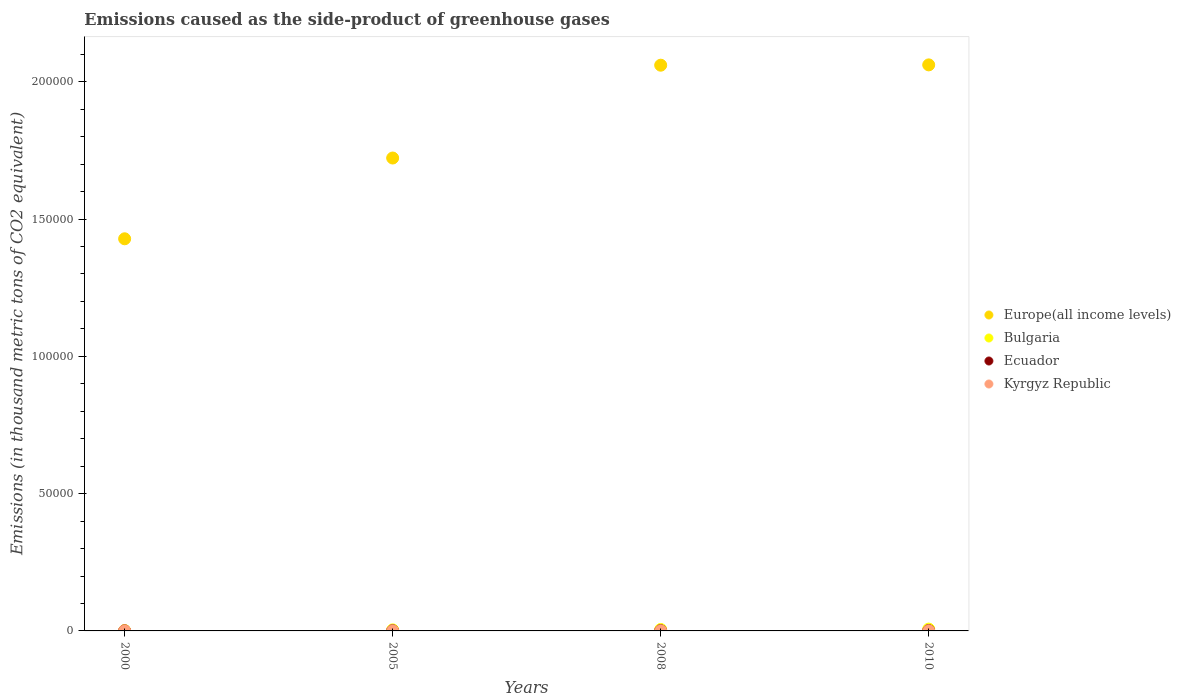What is the emissions caused as the side-product of greenhouse gases in Europe(all income levels) in 2005?
Your answer should be very brief. 1.72e+05. Across all years, what is the maximum emissions caused as the side-product of greenhouse gases in Europe(all income levels)?
Your response must be concise. 2.06e+05. Across all years, what is the minimum emissions caused as the side-product of greenhouse gases in Europe(all income levels)?
Give a very brief answer. 1.43e+05. In which year was the emissions caused as the side-product of greenhouse gases in Kyrgyz Republic maximum?
Your response must be concise. 2010. What is the total emissions caused as the side-product of greenhouse gases in Ecuador in the graph?
Your answer should be very brief. 272.6. What is the difference between the emissions caused as the side-product of greenhouse gases in Europe(all income levels) in 2000 and that in 2010?
Provide a succinct answer. -6.33e+04. What is the difference between the emissions caused as the side-product of greenhouse gases in Bulgaria in 2005 and the emissions caused as the side-product of greenhouse gases in Ecuador in 2000?
Offer a terse response. 360.4. What is the average emissions caused as the side-product of greenhouse gases in Kyrgyz Republic per year?
Make the answer very short. 27.17. In the year 2000, what is the difference between the emissions caused as the side-product of greenhouse gases in Kyrgyz Republic and emissions caused as the side-product of greenhouse gases in Bulgaria?
Your answer should be compact. -114.3. What is the ratio of the emissions caused as the side-product of greenhouse gases in Kyrgyz Republic in 2000 to that in 2008?
Offer a very short reply. 0.23. Is the emissions caused as the side-product of greenhouse gases in Ecuador in 2008 less than that in 2010?
Your response must be concise. Yes. Is the difference between the emissions caused as the side-product of greenhouse gases in Kyrgyz Republic in 2000 and 2005 greater than the difference between the emissions caused as the side-product of greenhouse gases in Bulgaria in 2000 and 2005?
Provide a short and direct response. Yes. What is the difference between the highest and the second highest emissions caused as the side-product of greenhouse gases in Europe(all income levels)?
Give a very brief answer. 115.6. What is the difference between the highest and the lowest emissions caused as the side-product of greenhouse gases in Ecuador?
Provide a short and direct response. 84.3. In how many years, is the emissions caused as the side-product of greenhouse gases in Bulgaria greater than the average emissions caused as the side-product of greenhouse gases in Bulgaria taken over all years?
Your answer should be very brief. 2. Is it the case that in every year, the sum of the emissions caused as the side-product of greenhouse gases in Bulgaria and emissions caused as the side-product of greenhouse gases in Kyrgyz Republic  is greater than the sum of emissions caused as the side-product of greenhouse gases in Ecuador and emissions caused as the side-product of greenhouse gases in Europe(all income levels)?
Offer a terse response. No. Is it the case that in every year, the sum of the emissions caused as the side-product of greenhouse gases in Bulgaria and emissions caused as the side-product of greenhouse gases in Kyrgyz Republic  is greater than the emissions caused as the side-product of greenhouse gases in Ecuador?
Make the answer very short. Yes. What is the difference between two consecutive major ticks on the Y-axis?
Your answer should be very brief. 5.00e+04. Where does the legend appear in the graph?
Keep it short and to the point. Center right. How many legend labels are there?
Give a very brief answer. 4. How are the legend labels stacked?
Your answer should be compact. Vertical. What is the title of the graph?
Offer a terse response. Emissions caused as the side-product of greenhouse gases. What is the label or title of the Y-axis?
Ensure brevity in your answer.  Emissions (in thousand metric tons of CO2 equivalent). What is the Emissions (in thousand metric tons of CO2 equivalent) in Europe(all income levels) in 2000?
Provide a short and direct response. 1.43e+05. What is the Emissions (in thousand metric tons of CO2 equivalent) of Bulgaria in 2000?
Your answer should be very brief. 122.2. What is the Emissions (in thousand metric tons of CO2 equivalent) of Europe(all income levels) in 2005?
Ensure brevity in your answer.  1.72e+05. What is the Emissions (in thousand metric tons of CO2 equivalent) of Bulgaria in 2005?
Offer a very short reply. 380.1. What is the Emissions (in thousand metric tons of CO2 equivalent) of Ecuador in 2005?
Make the answer very short. 62.2. What is the Emissions (in thousand metric tons of CO2 equivalent) in Kyrgyz Republic in 2005?
Your answer should be very brief. 24. What is the Emissions (in thousand metric tons of CO2 equivalent) in Europe(all income levels) in 2008?
Your answer should be compact. 2.06e+05. What is the Emissions (in thousand metric tons of CO2 equivalent) of Bulgaria in 2008?
Provide a succinct answer. 526.2. What is the Emissions (in thousand metric tons of CO2 equivalent) in Ecuador in 2008?
Provide a succinct answer. 86.7. What is the Emissions (in thousand metric tons of CO2 equivalent) of Kyrgyz Republic in 2008?
Your response must be concise. 34.8. What is the Emissions (in thousand metric tons of CO2 equivalent) of Europe(all income levels) in 2010?
Give a very brief answer. 2.06e+05. What is the Emissions (in thousand metric tons of CO2 equivalent) of Bulgaria in 2010?
Make the answer very short. 666. What is the Emissions (in thousand metric tons of CO2 equivalent) in Ecuador in 2010?
Your response must be concise. 104. Across all years, what is the maximum Emissions (in thousand metric tons of CO2 equivalent) of Europe(all income levels)?
Provide a short and direct response. 2.06e+05. Across all years, what is the maximum Emissions (in thousand metric tons of CO2 equivalent) in Bulgaria?
Offer a very short reply. 666. Across all years, what is the maximum Emissions (in thousand metric tons of CO2 equivalent) of Ecuador?
Your answer should be compact. 104. Across all years, what is the minimum Emissions (in thousand metric tons of CO2 equivalent) of Europe(all income levels)?
Provide a short and direct response. 1.43e+05. Across all years, what is the minimum Emissions (in thousand metric tons of CO2 equivalent) in Bulgaria?
Offer a very short reply. 122.2. Across all years, what is the minimum Emissions (in thousand metric tons of CO2 equivalent) in Kyrgyz Republic?
Ensure brevity in your answer.  7.9. What is the total Emissions (in thousand metric tons of CO2 equivalent) of Europe(all income levels) in the graph?
Make the answer very short. 7.27e+05. What is the total Emissions (in thousand metric tons of CO2 equivalent) of Bulgaria in the graph?
Offer a terse response. 1694.5. What is the total Emissions (in thousand metric tons of CO2 equivalent) in Ecuador in the graph?
Ensure brevity in your answer.  272.6. What is the total Emissions (in thousand metric tons of CO2 equivalent) in Kyrgyz Republic in the graph?
Offer a terse response. 108.7. What is the difference between the Emissions (in thousand metric tons of CO2 equivalent) of Europe(all income levels) in 2000 and that in 2005?
Make the answer very short. -2.94e+04. What is the difference between the Emissions (in thousand metric tons of CO2 equivalent) of Bulgaria in 2000 and that in 2005?
Offer a terse response. -257.9. What is the difference between the Emissions (in thousand metric tons of CO2 equivalent) in Ecuador in 2000 and that in 2005?
Give a very brief answer. -42.5. What is the difference between the Emissions (in thousand metric tons of CO2 equivalent) in Kyrgyz Republic in 2000 and that in 2005?
Provide a succinct answer. -16.1. What is the difference between the Emissions (in thousand metric tons of CO2 equivalent) in Europe(all income levels) in 2000 and that in 2008?
Your answer should be very brief. -6.32e+04. What is the difference between the Emissions (in thousand metric tons of CO2 equivalent) of Bulgaria in 2000 and that in 2008?
Provide a succinct answer. -404. What is the difference between the Emissions (in thousand metric tons of CO2 equivalent) in Ecuador in 2000 and that in 2008?
Offer a terse response. -67. What is the difference between the Emissions (in thousand metric tons of CO2 equivalent) in Kyrgyz Republic in 2000 and that in 2008?
Provide a succinct answer. -26.9. What is the difference between the Emissions (in thousand metric tons of CO2 equivalent) in Europe(all income levels) in 2000 and that in 2010?
Your response must be concise. -6.33e+04. What is the difference between the Emissions (in thousand metric tons of CO2 equivalent) in Bulgaria in 2000 and that in 2010?
Provide a short and direct response. -543.8. What is the difference between the Emissions (in thousand metric tons of CO2 equivalent) in Ecuador in 2000 and that in 2010?
Give a very brief answer. -84.3. What is the difference between the Emissions (in thousand metric tons of CO2 equivalent) of Kyrgyz Republic in 2000 and that in 2010?
Your response must be concise. -34.1. What is the difference between the Emissions (in thousand metric tons of CO2 equivalent) of Europe(all income levels) in 2005 and that in 2008?
Your answer should be very brief. -3.38e+04. What is the difference between the Emissions (in thousand metric tons of CO2 equivalent) in Bulgaria in 2005 and that in 2008?
Provide a succinct answer. -146.1. What is the difference between the Emissions (in thousand metric tons of CO2 equivalent) in Ecuador in 2005 and that in 2008?
Ensure brevity in your answer.  -24.5. What is the difference between the Emissions (in thousand metric tons of CO2 equivalent) of Europe(all income levels) in 2005 and that in 2010?
Provide a succinct answer. -3.39e+04. What is the difference between the Emissions (in thousand metric tons of CO2 equivalent) of Bulgaria in 2005 and that in 2010?
Make the answer very short. -285.9. What is the difference between the Emissions (in thousand metric tons of CO2 equivalent) in Ecuador in 2005 and that in 2010?
Keep it short and to the point. -41.8. What is the difference between the Emissions (in thousand metric tons of CO2 equivalent) of Kyrgyz Republic in 2005 and that in 2010?
Keep it short and to the point. -18. What is the difference between the Emissions (in thousand metric tons of CO2 equivalent) in Europe(all income levels) in 2008 and that in 2010?
Make the answer very short. -115.6. What is the difference between the Emissions (in thousand metric tons of CO2 equivalent) in Bulgaria in 2008 and that in 2010?
Give a very brief answer. -139.8. What is the difference between the Emissions (in thousand metric tons of CO2 equivalent) of Ecuador in 2008 and that in 2010?
Ensure brevity in your answer.  -17.3. What is the difference between the Emissions (in thousand metric tons of CO2 equivalent) of Europe(all income levels) in 2000 and the Emissions (in thousand metric tons of CO2 equivalent) of Bulgaria in 2005?
Offer a very short reply. 1.42e+05. What is the difference between the Emissions (in thousand metric tons of CO2 equivalent) of Europe(all income levels) in 2000 and the Emissions (in thousand metric tons of CO2 equivalent) of Ecuador in 2005?
Your answer should be very brief. 1.43e+05. What is the difference between the Emissions (in thousand metric tons of CO2 equivalent) of Europe(all income levels) in 2000 and the Emissions (in thousand metric tons of CO2 equivalent) of Kyrgyz Republic in 2005?
Your answer should be compact. 1.43e+05. What is the difference between the Emissions (in thousand metric tons of CO2 equivalent) of Bulgaria in 2000 and the Emissions (in thousand metric tons of CO2 equivalent) of Kyrgyz Republic in 2005?
Your answer should be very brief. 98.2. What is the difference between the Emissions (in thousand metric tons of CO2 equivalent) of Ecuador in 2000 and the Emissions (in thousand metric tons of CO2 equivalent) of Kyrgyz Republic in 2005?
Ensure brevity in your answer.  -4.3. What is the difference between the Emissions (in thousand metric tons of CO2 equivalent) in Europe(all income levels) in 2000 and the Emissions (in thousand metric tons of CO2 equivalent) in Bulgaria in 2008?
Provide a short and direct response. 1.42e+05. What is the difference between the Emissions (in thousand metric tons of CO2 equivalent) of Europe(all income levels) in 2000 and the Emissions (in thousand metric tons of CO2 equivalent) of Ecuador in 2008?
Your answer should be very brief. 1.43e+05. What is the difference between the Emissions (in thousand metric tons of CO2 equivalent) in Europe(all income levels) in 2000 and the Emissions (in thousand metric tons of CO2 equivalent) in Kyrgyz Republic in 2008?
Your answer should be compact. 1.43e+05. What is the difference between the Emissions (in thousand metric tons of CO2 equivalent) of Bulgaria in 2000 and the Emissions (in thousand metric tons of CO2 equivalent) of Ecuador in 2008?
Give a very brief answer. 35.5. What is the difference between the Emissions (in thousand metric tons of CO2 equivalent) in Bulgaria in 2000 and the Emissions (in thousand metric tons of CO2 equivalent) in Kyrgyz Republic in 2008?
Keep it short and to the point. 87.4. What is the difference between the Emissions (in thousand metric tons of CO2 equivalent) of Ecuador in 2000 and the Emissions (in thousand metric tons of CO2 equivalent) of Kyrgyz Republic in 2008?
Provide a succinct answer. -15.1. What is the difference between the Emissions (in thousand metric tons of CO2 equivalent) of Europe(all income levels) in 2000 and the Emissions (in thousand metric tons of CO2 equivalent) of Bulgaria in 2010?
Your response must be concise. 1.42e+05. What is the difference between the Emissions (in thousand metric tons of CO2 equivalent) of Europe(all income levels) in 2000 and the Emissions (in thousand metric tons of CO2 equivalent) of Ecuador in 2010?
Offer a terse response. 1.43e+05. What is the difference between the Emissions (in thousand metric tons of CO2 equivalent) of Europe(all income levels) in 2000 and the Emissions (in thousand metric tons of CO2 equivalent) of Kyrgyz Republic in 2010?
Offer a very short reply. 1.43e+05. What is the difference between the Emissions (in thousand metric tons of CO2 equivalent) in Bulgaria in 2000 and the Emissions (in thousand metric tons of CO2 equivalent) in Kyrgyz Republic in 2010?
Keep it short and to the point. 80.2. What is the difference between the Emissions (in thousand metric tons of CO2 equivalent) of Ecuador in 2000 and the Emissions (in thousand metric tons of CO2 equivalent) of Kyrgyz Republic in 2010?
Provide a short and direct response. -22.3. What is the difference between the Emissions (in thousand metric tons of CO2 equivalent) of Europe(all income levels) in 2005 and the Emissions (in thousand metric tons of CO2 equivalent) of Bulgaria in 2008?
Provide a succinct answer. 1.72e+05. What is the difference between the Emissions (in thousand metric tons of CO2 equivalent) in Europe(all income levels) in 2005 and the Emissions (in thousand metric tons of CO2 equivalent) in Ecuador in 2008?
Your answer should be very brief. 1.72e+05. What is the difference between the Emissions (in thousand metric tons of CO2 equivalent) in Europe(all income levels) in 2005 and the Emissions (in thousand metric tons of CO2 equivalent) in Kyrgyz Republic in 2008?
Offer a terse response. 1.72e+05. What is the difference between the Emissions (in thousand metric tons of CO2 equivalent) of Bulgaria in 2005 and the Emissions (in thousand metric tons of CO2 equivalent) of Ecuador in 2008?
Provide a short and direct response. 293.4. What is the difference between the Emissions (in thousand metric tons of CO2 equivalent) in Bulgaria in 2005 and the Emissions (in thousand metric tons of CO2 equivalent) in Kyrgyz Republic in 2008?
Give a very brief answer. 345.3. What is the difference between the Emissions (in thousand metric tons of CO2 equivalent) in Ecuador in 2005 and the Emissions (in thousand metric tons of CO2 equivalent) in Kyrgyz Republic in 2008?
Provide a short and direct response. 27.4. What is the difference between the Emissions (in thousand metric tons of CO2 equivalent) of Europe(all income levels) in 2005 and the Emissions (in thousand metric tons of CO2 equivalent) of Bulgaria in 2010?
Offer a terse response. 1.72e+05. What is the difference between the Emissions (in thousand metric tons of CO2 equivalent) of Europe(all income levels) in 2005 and the Emissions (in thousand metric tons of CO2 equivalent) of Ecuador in 2010?
Your response must be concise. 1.72e+05. What is the difference between the Emissions (in thousand metric tons of CO2 equivalent) of Europe(all income levels) in 2005 and the Emissions (in thousand metric tons of CO2 equivalent) of Kyrgyz Republic in 2010?
Your answer should be compact. 1.72e+05. What is the difference between the Emissions (in thousand metric tons of CO2 equivalent) of Bulgaria in 2005 and the Emissions (in thousand metric tons of CO2 equivalent) of Ecuador in 2010?
Your answer should be compact. 276.1. What is the difference between the Emissions (in thousand metric tons of CO2 equivalent) in Bulgaria in 2005 and the Emissions (in thousand metric tons of CO2 equivalent) in Kyrgyz Republic in 2010?
Make the answer very short. 338.1. What is the difference between the Emissions (in thousand metric tons of CO2 equivalent) of Ecuador in 2005 and the Emissions (in thousand metric tons of CO2 equivalent) of Kyrgyz Republic in 2010?
Your response must be concise. 20.2. What is the difference between the Emissions (in thousand metric tons of CO2 equivalent) in Europe(all income levels) in 2008 and the Emissions (in thousand metric tons of CO2 equivalent) in Bulgaria in 2010?
Ensure brevity in your answer.  2.05e+05. What is the difference between the Emissions (in thousand metric tons of CO2 equivalent) of Europe(all income levels) in 2008 and the Emissions (in thousand metric tons of CO2 equivalent) of Ecuador in 2010?
Offer a terse response. 2.06e+05. What is the difference between the Emissions (in thousand metric tons of CO2 equivalent) in Europe(all income levels) in 2008 and the Emissions (in thousand metric tons of CO2 equivalent) in Kyrgyz Republic in 2010?
Ensure brevity in your answer.  2.06e+05. What is the difference between the Emissions (in thousand metric tons of CO2 equivalent) in Bulgaria in 2008 and the Emissions (in thousand metric tons of CO2 equivalent) in Ecuador in 2010?
Your answer should be very brief. 422.2. What is the difference between the Emissions (in thousand metric tons of CO2 equivalent) of Bulgaria in 2008 and the Emissions (in thousand metric tons of CO2 equivalent) of Kyrgyz Republic in 2010?
Your response must be concise. 484.2. What is the difference between the Emissions (in thousand metric tons of CO2 equivalent) in Ecuador in 2008 and the Emissions (in thousand metric tons of CO2 equivalent) in Kyrgyz Republic in 2010?
Offer a very short reply. 44.7. What is the average Emissions (in thousand metric tons of CO2 equivalent) in Europe(all income levels) per year?
Your response must be concise. 1.82e+05. What is the average Emissions (in thousand metric tons of CO2 equivalent) in Bulgaria per year?
Give a very brief answer. 423.62. What is the average Emissions (in thousand metric tons of CO2 equivalent) of Ecuador per year?
Your answer should be compact. 68.15. What is the average Emissions (in thousand metric tons of CO2 equivalent) of Kyrgyz Republic per year?
Provide a short and direct response. 27.18. In the year 2000, what is the difference between the Emissions (in thousand metric tons of CO2 equivalent) of Europe(all income levels) and Emissions (in thousand metric tons of CO2 equivalent) of Bulgaria?
Keep it short and to the point. 1.43e+05. In the year 2000, what is the difference between the Emissions (in thousand metric tons of CO2 equivalent) of Europe(all income levels) and Emissions (in thousand metric tons of CO2 equivalent) of Ecuador?
Your answer should be very brief. 1.43e+05. In the year 2000, what is the difference between the Emissions (in thousand metric tons of CO2 equivalent) of Europe(all income levels) and Emissions (in thousand metric tons of CO2 equivalent) of Kyrgyz Republic?
Provide a succinct answer. 1.43e+05. In the year 2000, what is the difference between the Emissions (in thousand metric tons of CO2 equivalent) of Bulgaria and Emissions (in thousand metric tons of CO2 equivalent) of Ecuador?
Provide a short and direct response. 102.5. In the year 2000, what is the difference between the Emissions (in thousand metric tons of CO2 equivalent) in Bulgaria and Emissions (in thousand metric tons of CO2 equivalent) in Kyrgyz Republic?
Make the answer very short. 114.3. In the year 2000, what is the difference between the Emissions (in thousand metric tons of CO2 equivalent) in Ecuador and Emissions (in thousand metric tons of CO2 equivalent) in Kyrgyz Republic?
Ensure brevity in your answer.  11.8. In the year 2005, what is the difference between the Emissions (in thousand metric tons of CO2 equivalent) in Europe(all income levels) and Emissions (in thousand metric tons of CO2 equivalent) in Bulgaria?
Provide a short and direct response. 1.72e+05. In the year 2005, what is the difference between the Emissions (in thousand metric tons of CO2 equivalent) in Europe(all income levels) and Emissions (in thousand metric tons of CO2 equivalent) in Ecuador?
Your answer should be very brief. 1.72e+05. In the year 2005, what is the difference between the Emissions (in thousand metric tons of CO2 equivalent) of Europe(all income levels) and Emissions (in thousand metric tons of CO2 equivalent) of Kyrgyz Republic?
Your response must be concise. 1.72e+05. In the year 2005, what is the difference between the Emissions (in thousand metric tons of CO2 equivalent) in Bulgaria and Emissions (in thousand metric tons of CO2 equivalent) in Ecuador?
Your answer should be compact. 317.9. In the year 2005, what is the difference between the Emissions (in thousand metric tons of CO2 equivalent) in Bulgaria and Emissions (in thousand metric tons of CO2 equivalent) in Kyrgyz Republic?
Ensure brevity in your answer.  356.1. In the year 2005, what is the difference between the Emissions (in thousand metric tons of CO2 equivalent) of Ecuador and Emissions (in thousand metric tons of CO2 equivalent) of Kyrgyz Republic?
Offer a terse response. 38.2. In the year 2008, what is the difference between the Emissions (in thousand metric tons of CO2 equivalent) in Europe(all income levels) and Emissions (in thousand metric tons of CO2 equivalent) in Bulgaria?
Offer a terse response. 2.06e+05. In the year 2008, what is the difference between the Emissions (in thousand metric tons of CO2 equivalent) of Europe(all income levels) and Emissions (in thousand metric tons of CO2 equivalent) of Ecuador?
Provide a short and direct response. 2.06e+05. In the year 2008, what is the difference between the Emissions (in thousand metric tons of CO2 equivalent) of Europe(all income levels) and Emissions (in thousand metric tons of CO2 equivalent) of Kyrgyz Republic?
Make the answer very short. 2.06e+05. In the year 2008, what is the difference between the Emissions (in thousand metric tons of CO2 equivalent) in Bulgaria and Emissions (in thousand metric tons of CO2 equivalent) in Ecuador?
Ensure brevity in your answer.  439.5. In the year 2008, what is the difference between the Emissions (in thousand metric tons of CO2 equivalent) of Bulgaria and Emissions (in thousand metric tons of CO2 equivalent) of Kyrgyz Republic?
Offer a very short reply. 491.4. In the year 2008, what is the difference between the Emissions (in thousand metric tons of CO2 equivalent) of Ecuador and Emissions (in thousand metric tons of CO2 equivalent) of Kyrgyz Republic?
Keep it short and to the point. 51.9. In the year 2010, what is the difference between the Emissions (in thousand metric tons of CO2 equivalent) in Europe(all income levels) and Emissions (in thousand metric tons of CO2 equivalent) in Bulgaria?
Offer a terse response. 2.06e+05. In the year 2010, what is the difference between the Emissions (in thousand metric tons of CO2 equivalent) of Europe(all income levels) and Emissions (in thousand metric tons of CO2 equivalent) of Ecuador?
Make the answer very short. 2.06e+05. In the year 2010, what is the difference between the Emissions (in thousand metric tons of CO2 equivalent) of Europe(all income levels) and Emissions (in thousand metric tons of CO2 equivalent) of Kyrgyz Republic?
Offer a very short reply. 2.06e+05. In the year 2010, what is the difference between the Emissions (in thousand metric tons of CO2 equivalent) in Bulgaria and Emissions (in thousand metric tons of CO2 equivalent) in Ecuador?
Your answer should be compact. 562. In the year 2010, what is the difference between the Emissions (in thousand metric tons of CO2 equivalent) in Bulgaria and Emissions (in thousand metric tons of CO2 equivalent) in Kyrgyz Republic?
Your response must be concise. 624. In the year 2010, what is the difference between the Emissions (in thousand metric tons of CO2 equivalent) in Ecuador and Emissions (in thousand metric tons of CO2 equivalent) in Kyrgyz Republic?
Offer a very short reply. 62. What is the ratio of the Emissions (in thousand metric tons of CO2 equivalent) of Europe(all income levels) in 2000 to that in 2005?
Your response must be concise. 0.83. What is the ratio of the Emissions (in thousand metric tons of CO2 equivalent) of Bulgaria in 2000 to that in 2005?
Ensure brevity in your answer.  0.32. What is the ratio of the Emissions (in thousand metric tons of CO2 equivalent) of Ecuador in 2000 to that in 2005?
Offer a terse response. 0.32. What is the ratio of the Emissions (in thousand metric tons of CO2 equivalent) of Kyrgyz Republic in 2000 to that in 2005?
Give a very brief answer. 0.33. What is the ratio of the Emissions (in thousand metric tons of CO2 equivalent) in Europe(all income levels) in 2000 to that in 2008?
Keep it short and to the point. 0.69. What is the ratio of the Emissions (in thousand metric tons of CO2 equivalent) of Bulgaria in 2000 to that in 2008?
Your answer should be compact. 0.23. What is the ratio of the Emissions (in thousand metric tons of CO2 equivalent) of Ecuador in 2000 to that in 2008?
Your answer should be compact. 0.23. What is the ratio of the Emissions (in thousand metric tons of CO2 equivalent) of Kyrgyz Republic in 2000 to that in 2008?
Offer a very short reply. 0.23. What is the ratio of the Emissions (in thousand metric tons of CO2 equivalent) in Europe(all income levels) in 2000 to that in 2010?
Provide a short and direct response. 0.69. What is the ratio of the Emissions (in thousand metric tons of CO2 equivalent) in Bulgaria in 2000 to that in 2010?
Ensure brevity in your answer.  0.18. What is the ratio of the Emissions (in thousand metric tons of CO2 equivalent) in Ecuador in 2000 to that in 2010?
Ensure brevity in your answer.  0.19. What is the ratio of the Emissions (in thousand metric tons of CO2 equivalent) in Kyrgyz Republic in 2000 to that in 2010?
Provide a succinct answer. 0.19. What is the ratio of the Emissions (in thousand metric tons of CO2 equivalent) of Europe(all income levels) in 2005 to that in 2008?
Provide a short and direct response. 0.84. What is the ratio of the Emissions (in thousand metric tons of CO2 equivalent) of Bulgaria in 2005 to that in 2008?
Provide a succinct answer. 0.72. What is the ratio of the Emissions (in thousand metric tons of CO2 equivalent) in Ecuador in 2005 to that in 2008?
Give a very brief answer. 0.72. What is the ratio of the Emissions (in thousand metric tons of CO2 equivalent) in Kyrgyz Republic in 2005 to that in 2008?
Your response must be concise. 0.69. What is the ratio of the Emissions (in thousand metric tons of CO2 equivalent) in Europe(all income levels) in 2005 to that in 2010?
Offer a very short reply. 0.84. What is the ratio of the Emissions (in thousand metric tons of CO2 equivalent) of Bulgaria in 2005 to that in 2010?
Your answer should be very brief. 0.57. What is the ratio of the Emissions (in thousand metric tons of CO2 equivalent) of Ecuador in 2005 to that in 2010?
Give a very brief answer. 0.6. What is the ratio of the Emissions (in thousand metric tons of CO2 equivalent) of Europe(all income levels) in 2008 to that in 2010?
Provide a succinct answer. 1. What is the ratio of the Emissions (in thousand metric tons of CO2 equivalent) of Bulgaria in 2008 to that in 2010?
Provide a succinct answer. 0.79. What is the ratio of the Emissions (in thousand metric tons of CO2 equivalent) in Ecuador in 2008 to that in 2010?
Provide a succinct answer. 0.83. What is the ratio of the Emissions (in thousand metric tons of CO2 equivalent) of Kyrgyz Republic in 2008 to that in 2010?
Provide a succinct answer. 0.83. What is the difference between the highest and the second highest Emissions (in thousand metric tons of CO2 equivalent) in Europe(all income levels)?
Make the answer very short. 115.6. What is the difference between the highest and the second highest Emissions (in thousand metric tons of CO2 equivalent) of Bulgaria?
Offer a terse response. 139.8. What is the difference between the highest and the lowest Emissions (in thousand metric tons of CO2 equivalent) in Europe(all income levels)?
Ensure brevity in your answer.  6.33e+04. What is the difference between the highest and the lowest Emissions (in thousand metric tons of CO2 equivalent) in Bulgaria?
Your answer should be very brief. 543.8. What is the difference between the highest and the lowest Emissions (in thousand metric tons of CO2 equivalent) of Ecuador?
Offer a terse response. 84.3. What is the difference between the highest and the lowest Emissions (in thousand metric tons of CO2 equivalent) in Kyrgyz Republic?
Your answer should be compact. 34.1. 